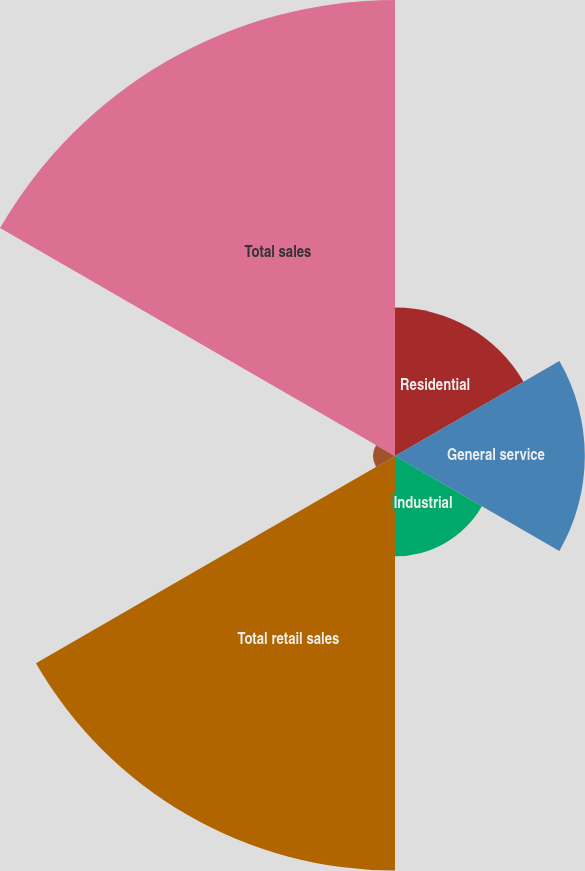Convert chart to OTSL. <chart><loc_0><loc_0><loc_500><loc_500><pie_chart><fcel>Residential<fcel>General service<fcel>Industrial<fcel>Total retail sales<fcel>Wholesale and other sales<fcel>Total sales<nl><fcel>11.15%<fcel>14.26%<fcel>7.54%<fcel>31.15%<fcel>1.64%<fcel>34.26%<nl></chart> 